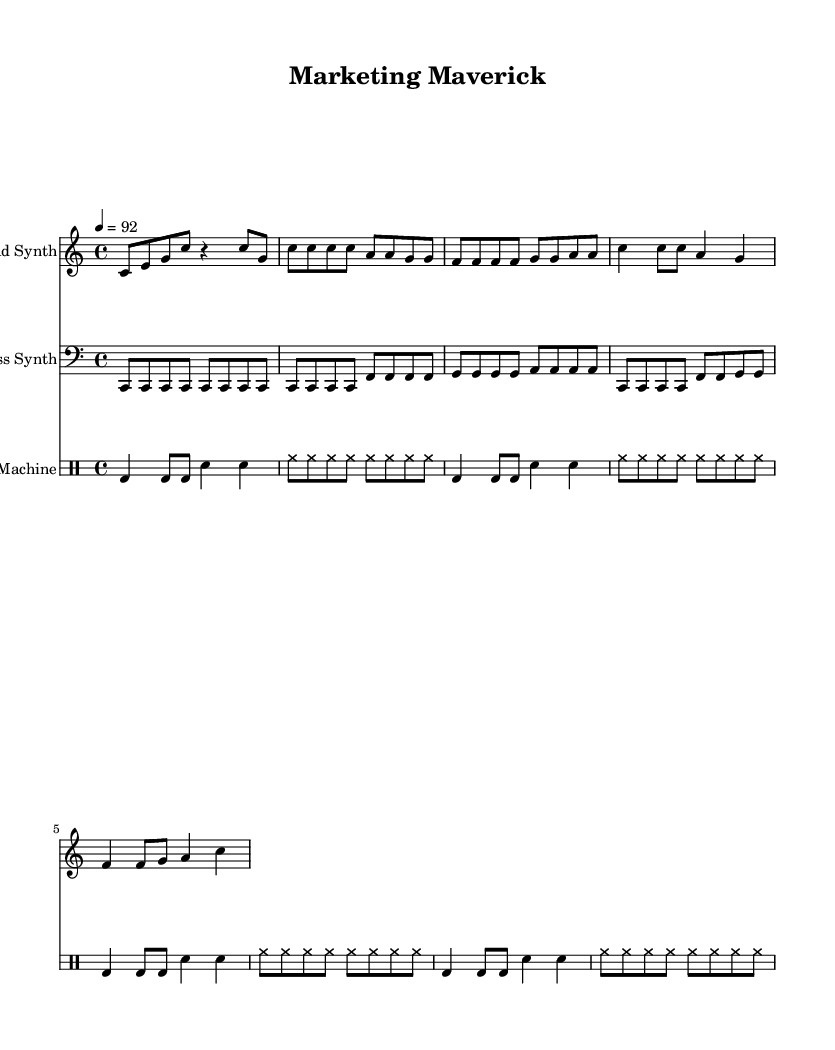What is the key signature of this music? The key signature listed in the music is C major, indicated at the beginning of the score. C major has no sharps or flats, and is identified at the start of the staff.
Answer: C major What is the time signature of the piece? The time signature is found at the beginning of the score, stated as 4/4. This means there are four beats in each measure and the quarter note gets the beat.
Answer: 4/4 What is the tempo marking for this piece? The tempo marking is located near the top of the score, listed as "4 = 92". This indicates that there are 92 beats per minute.
Answer: 92 How many measures are present in the verse section? The verse section consists of two phrases, each repeated for a total of four measures, as counted in the "Lead Synth" staff.
Answer: 8 What instrument plays the lyrics? The lyrics in the music are assigned to the "Lead Synth" part, as specified in the "Lyrics" section. This part is where the vocal line for the rap is indicated.
Answer: Lead Synth What is the primary theme expressed in the lyrics? The lyrics focus on innovative strategies and brand success, making it clear that the piece is centered around marketing themes. This is derived from the phrases present in the "Lyrics" section.
Answer: Marketing How many different instruments are included in the score? The score includes three distinct instruments: "Lead Synth," "Bass Synth," and "Drum Machine." Each has its own staff line in the arrangement.
Answer: Three 